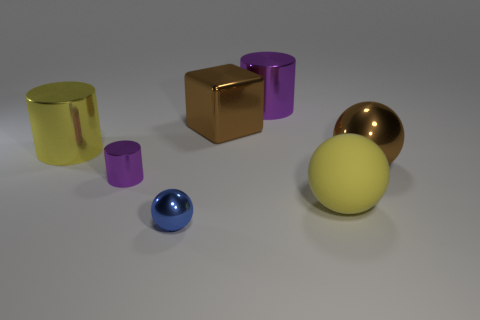Do the metal cube and the big metal ball have the same color?
Give a very brief answer. Yes. Do the tiny cylinder and the big metallic cylinder that is to the right of the tiny blue metallic thing have the same color?
Provide a short and direct response. Yes. The shiny object that is the same color as the metallic cube is what size?
Give a very brief answer. Large. There is a large object that is the same color as the large metal block; what is it made of?
Give a very brief answer. Metal. What number of other things are the same color as the large matte ball?
Your answer should be very brief. 1. What is the color of the metal ball that is to the left of the brown thing right of the yellow ball?
Provide a succinct answer. Blue. Is there a big object of the same color as the big block?
Give a very brief answer. Yes. What number of shiny objects are either purple objects or yellow blocks?
Offer a very short reply. 2. Are there any tiny purple cylinders that have the same material as the brown cube?
Your answer should be very brief. Yes. What number of large yellow things are to the right of the small purple cylinder and behind the brown metal sphere?
Ensure brevity in your answer.  0. 